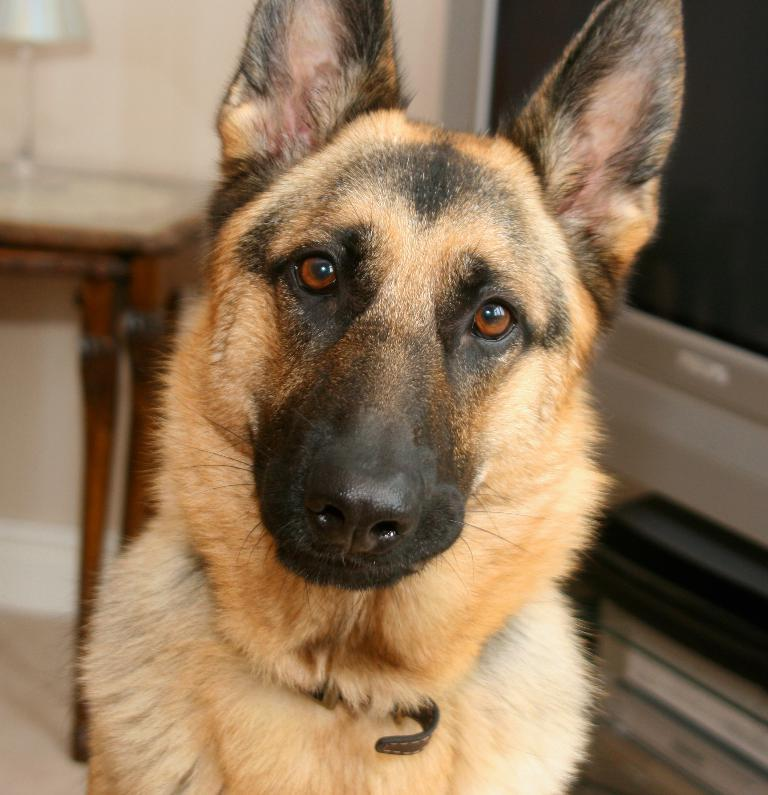What animal can be seen in the image? There is a dog in the image. What position is the dog in? The dog is sitting on the floor. What objects can be seen in the background of the image? There is a table and a television in the background of the image. What type of leather is the dog chewing on in the image? There is no leather present in the image; the dog is sitting on the floor. 